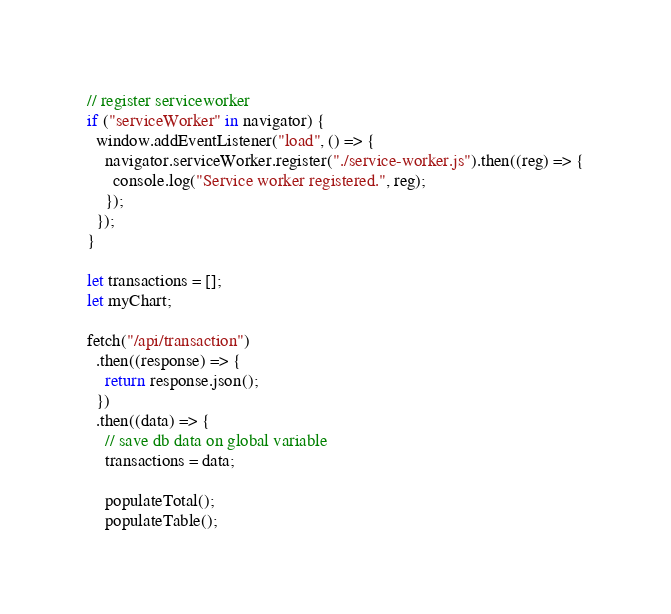Convert code to text. <code><loc_0><loc_0><loc_500><loc_500><_JavaScript_>// register serviceworker
if ("serviceWorker" in navigator) {
  window.addEventListener("load", () => {
    navigator.serviceWorker.register("./service-worker.js").then((reg) => {
      console.log("Service worker registered.", reg);
    });
  });
}

let transactions = [];
let myChart;

fetch("/api/transaction")
  .then((response) => {
    return response.json();
  })
  .then((data) => {
    // save db data on global variable
    transactions = data;

    populateTotal();
    populateTable();</code> 